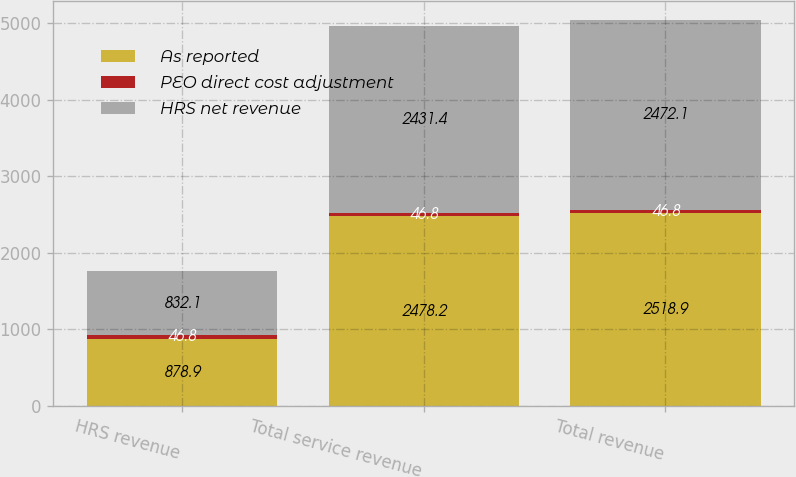Convert chart to OTSL. <chart><loc_0><loc_0><loc_500><loc_500><stacked_bar_chart><ecel><fcel>HRS revenue<fcel>Total service revenue<fcel>Total revenue<nl><fcel>As reported<fcel>878.9<fcel>2478.2<fcel>2518.9<nl><fcel>PEO direct cost adjustment<fcel>46.8<fcel>46.8<fcel>46.8<nl><fcel>HRS net revenue<fcel>832.1<fcel>2431.4<fcel>2472.1<nl></chart> 